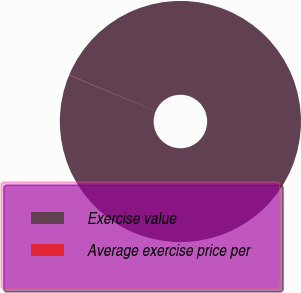Convert chart to OTSL. <chart><loc_0><loc_0><loc_500><loc_500><pie_chart><fcel>Exercise value<fcel>Average exercise price per<nl><fcel>99.97%<fcel>0.03%<nl></chart> 